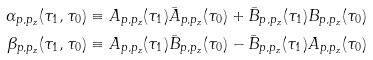<formula> <loc_0><loc_0><loc_500><loc_500>\alpha _ { p , p _ { z } } ( \tau _ { 1 } , \tau _ { 0 } ) & \equiv A _ { p , p _ { z } } ( \tau _ { 1 } ) \bar { A } _ { p , p _ { z } } ( \tau _ { 0 } ) + \bar { B } _ { p , p _ { z } } ( \tau _ { 1 } ) B _ { p , p _ { z } } ( \tau _ { 0 } ) \\ \beta _ { p , p _ { z } } ( \tau _ { 1 } , \tau _ { 0 } ) & \equiv A _ { p , p _ { z } } ( \tau _ { 1 } ) \bar { B } _ { p , p _ { z } } ( \tau _ { 0 } ) - \bar { B } _ { p , p _ { z } } ( \tau _ { 1 } ) A _ { p , p _ { z } } ( \tau _ { 0 } )</formula> 